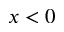<formula> <loc_0><loc_0><loc_500><loc_500>x < 0</formula> 